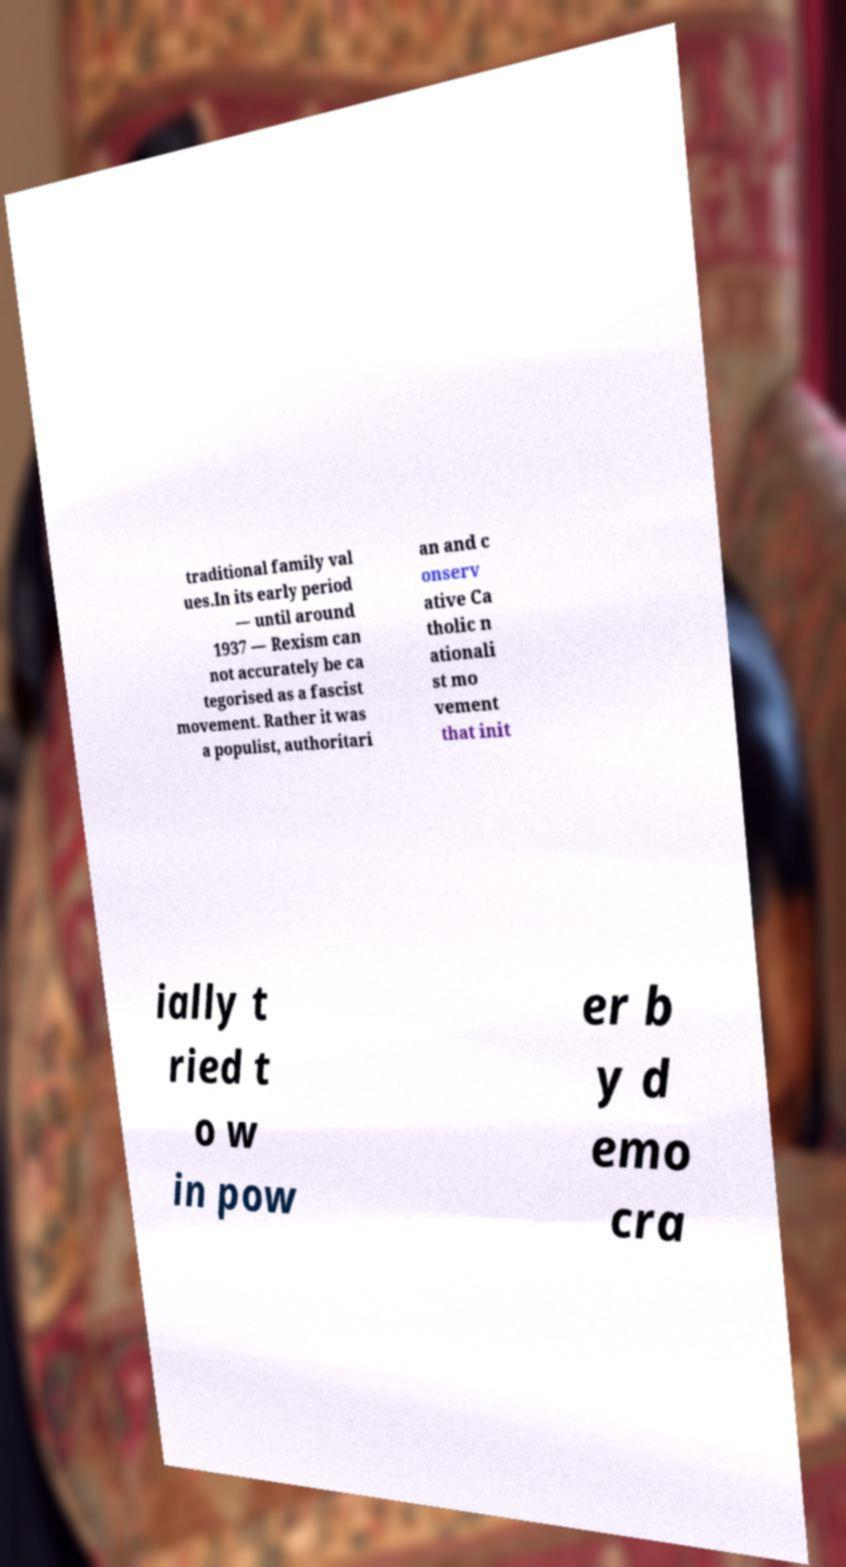Please read and relay the text visible in this image. What does it say? traditional family val ues.In its early period — until around 1937 — Rexism can not accurately be ca tegorised as a fascist movement. Rather it was a populist, authoritari an and c onserv ative Ca tholic n ationali st mo vement that init ially t ried t o w in pow er b y d emo cra 